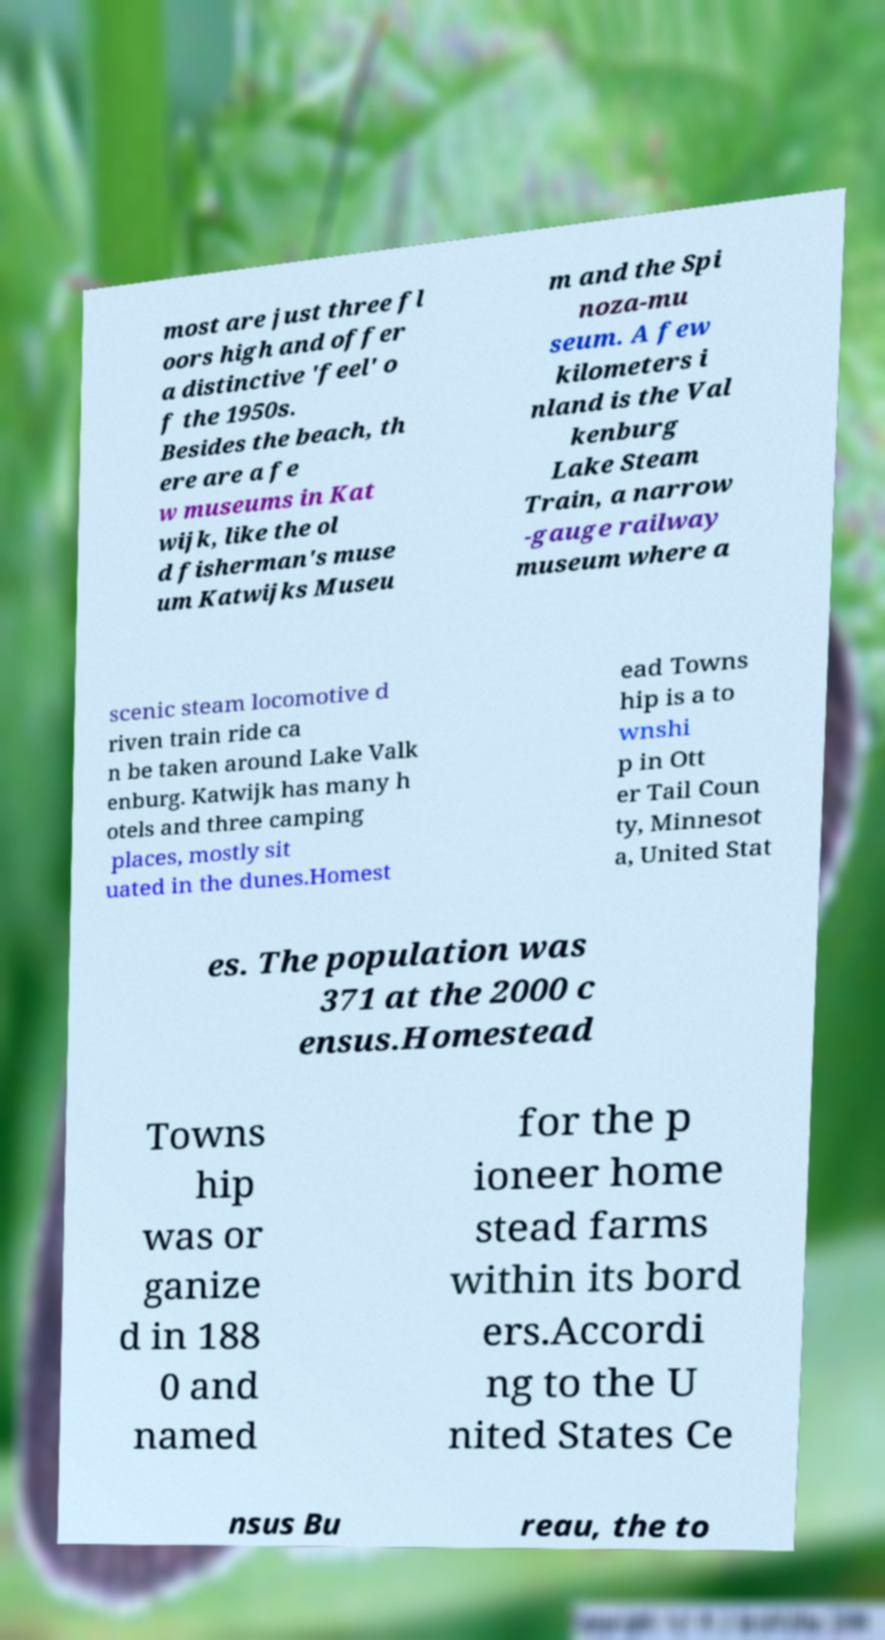I need the written content from this picture converted into text. Can you do that? most are just three fl oors high and offer a distinctive 'feel' o f the 1950s. Besides the beach, th ere are a fe w museums in Kat wijk, like the ol d fisherman's muse um Katwijks Museu m and the Spi noza-mu seum. A few kilometers i nland is the Val kenburg Lake Steam Train, a narrow -gauge railway museum where a scenic steam locomotive d riven train ride ca n be taken around Lake Valk enburg. Katwijk has many h otels and three camping places, mostly sit uated in the dunes.Homest ead Towns hip is a to wnshi p in Ott er Tail Coun ty, Minnesot a, United Stat es. The population was 371 at the 2000 c ensus.Homestead Towns hip was or ganize d in 188 0 and named for the p ioneer home stead farms within its bord ers.Accordi ng to the U nited States Ce nsus Bu reau, the to 